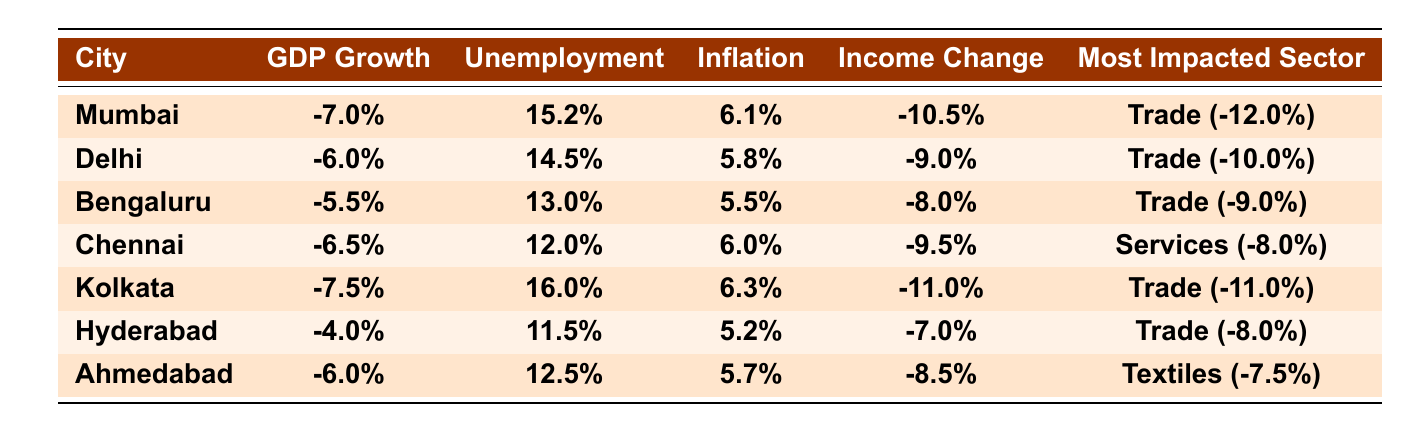What is the GDP growth rate of Kolkata? The table indicates the GDP growth rate for Kolkata as -7.5%.
Answer: -7.5% Which city has the highest unemployment rate? The highest unemployment rate is listed for Kolkata at 16.0%.
Answer: Kolkata What is the average income change across all cities? The average income change can be calculated by summing the individual changes: (-10.5 + -9.0 + -8.0 + -9.5 + -11.0 + -7.0 + -8.5) = -63.5, divided by 7 (the number of cities) gives -9.07%.
Answer: -9.07% Which city experienced the lowest GDP growth rate? Comparing the GDP growth rates listed, Kolkata at -7.5% has the lowest rate.
Answer: Kolkata Is the inflation rate in Hyderabad higher than in Bengaluru? The inflation rate for Hyderabad is 5.2%, while for Bengaluru, it is 5.5%. Since 5.2% is not higher than 5.5%, the statement is false.
Answer: No What is the sector most impacted in Mumbai? The table indicates that the most impacted sector in Mumbai is Trade, with an impact of -12.0%.
Answer: Trade Calculate the difference in unemployment rate between Mumbai and Chennai. The unemployment rate for Mumbai is 15.2% and for Chennai is 12.0%. The difference is 15.2% - 12.0% = 3.2%.
Answer: 3.2% Which city has the highest inflation rate? Examining the inflation rates, Kolkata has the highest at 6.3%.
Answer: Kolkata What is the overall impact on the manufacturing sector in Delhi? In Delhi, the table indicates a -4.0% impact on the manufacturing sector, signifying a contraction.
Answer: -4.0% How does the average income change in Hyderabad compare to Kolkata? Hyderabad's average income change is -7.0% while Kolkata's is -11.0%. Since -7.0% is greater than -11.0%, it indicates a smaller loss in Hyderabad compared to Kolkata.
Answer: Smaller loss in Hyderabad 